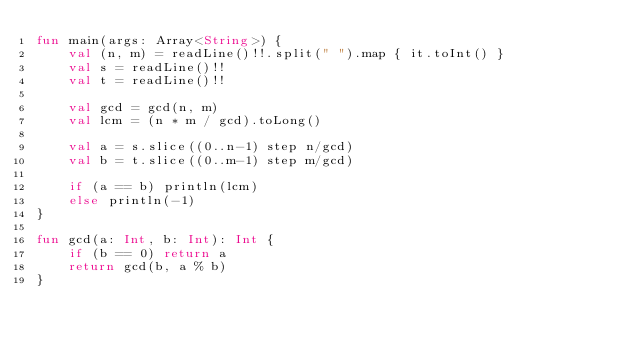<code> <loc_0><loc_0><loc_500><loc_500><_Kotlin_>fun main(args: Array<String>) {
    val (n, m) = readLine()!!.split(" ").map { it.toInt() }
    val s = readLine()!!
    val t = readLine()!!

    val gcd = gcd(n, m)
    val lcm = (n * m / gcd).toLong()

    val a = s.slice((0..n-1) step n/gcd)
    val b = t.slice((0..m-1) step m/gcd)

    if (a == b) println(lcm)
    else println(-1)
}

fun gcd(a: Int, b: Int): Int {
    if (b == 0) return a
    return gcd(b, a % b)
}</code> 